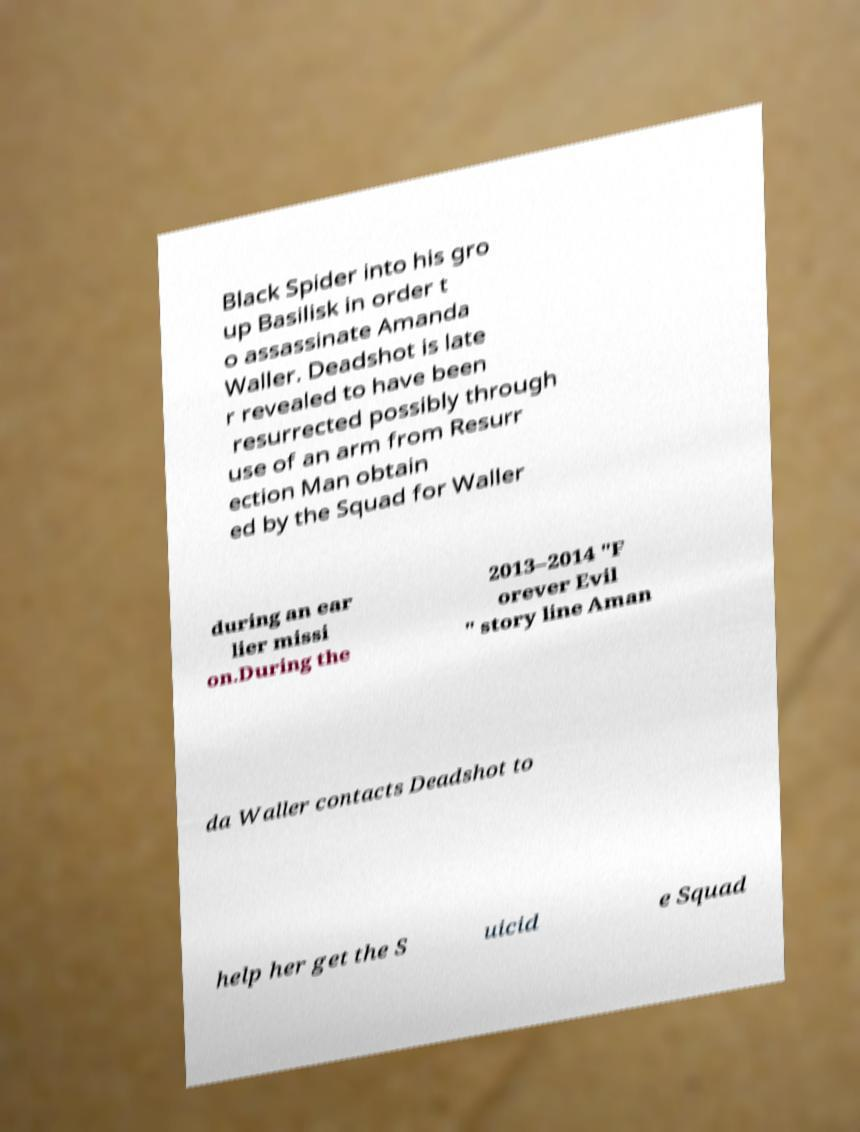Could you assist in decoding the text presented in this image and type it out clearly? Black Spider into his gro up Basilisk in order t o assassinate Amanda Waller. Deadshot is late r revealed to have been resurrected possibly through use of an arm from Resurr ection Man obtain ed by the Squad for Waller during an ear lier missi on.During the 2013–2014 "F orever Evil " story line Aman da Waller contacts Deadshot to help her get the S uicid e Squad 